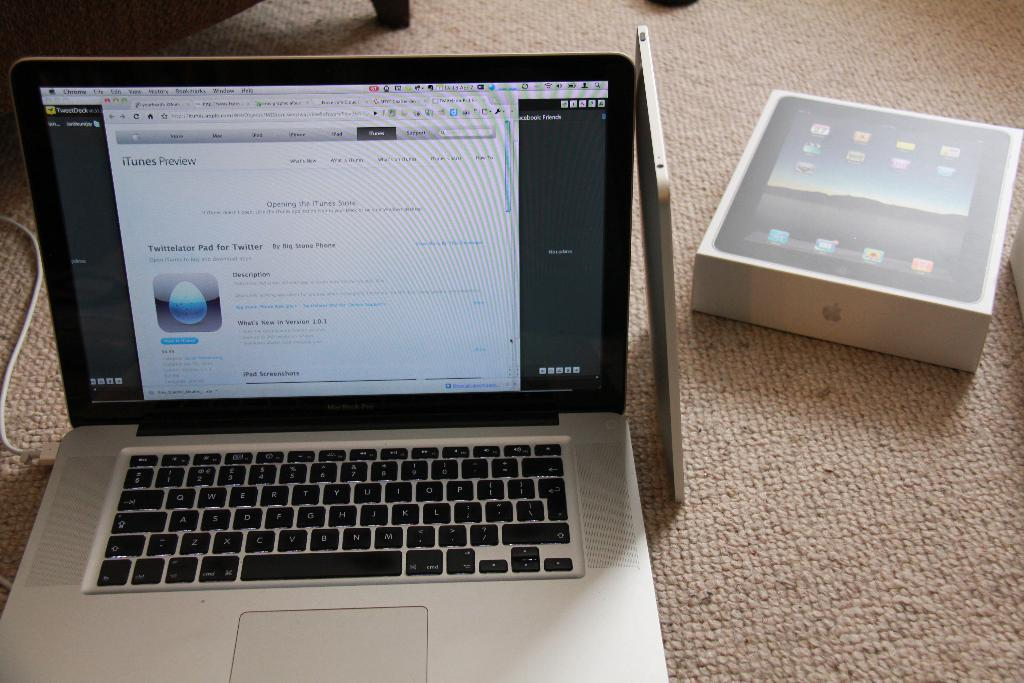Provide a one-sentence caption for the provided image. A Macbook shows a screen for an app called Twittelator Pad for Twitter on it. 